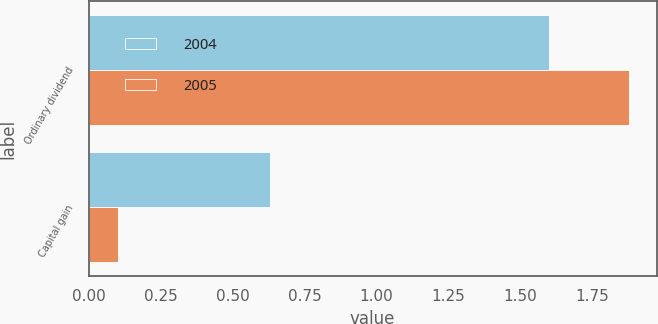<chart> <loc_0><loc_0><loc_500><loc_500><stacked_bar_chart><ecel><fcel>Ordinary dividend<fcel>Capital gain<nl><fcel>2004<fcel>1.6<fcel>0.63<nl><fcel>2005<fcel>1.88<fcel>0.1<nl></chart> 